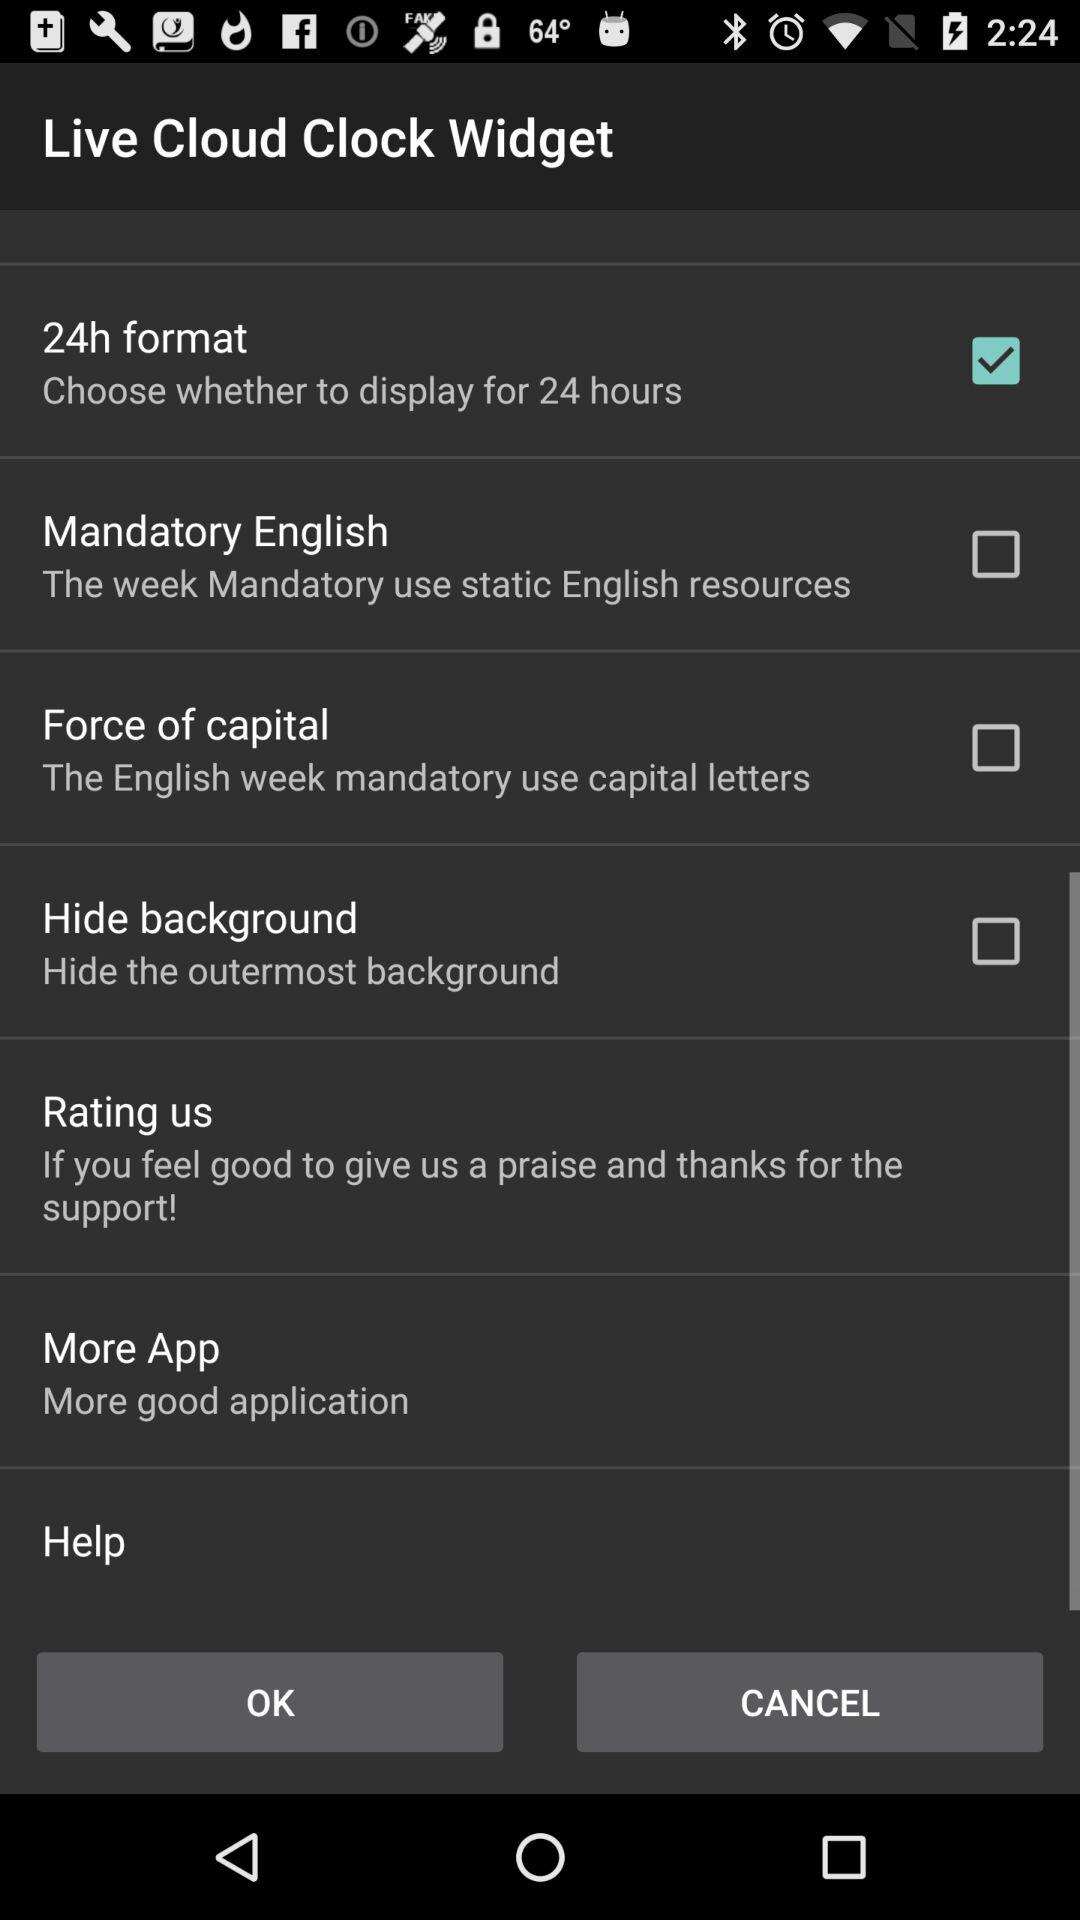What is the status of "Hide background"? The status of "Hide background" is "off". 